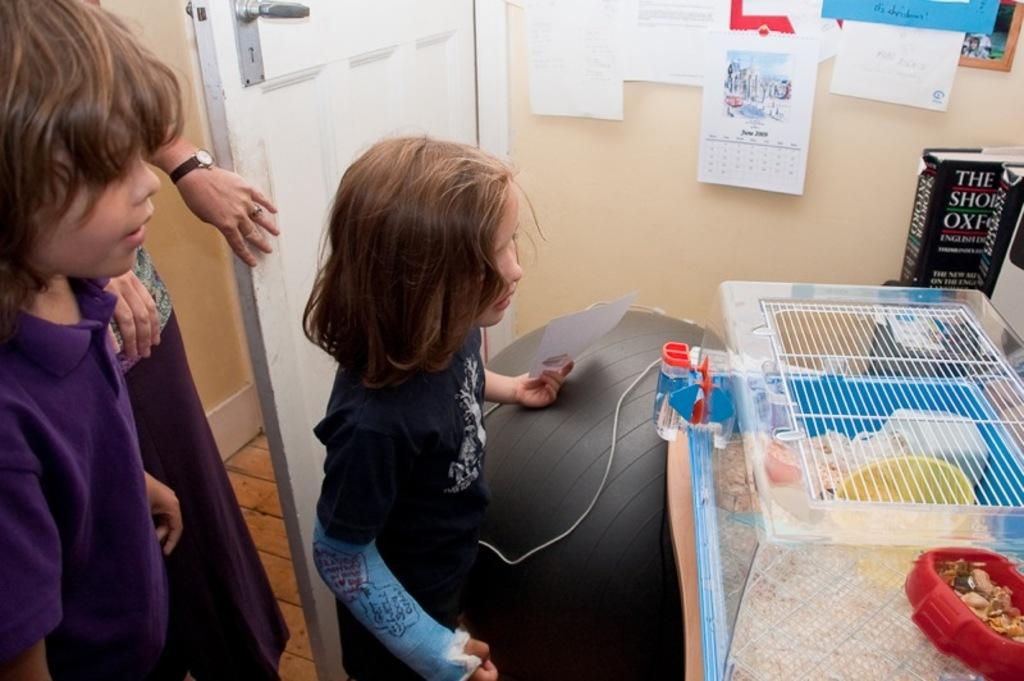<image>
Provide a brief description of the given image. two children looking at a hamster cage in the month of june 